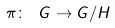<formula> <loc_0><loc_0><loc_500><loc_500>\pi \colon \ G \to G / H</formula> 